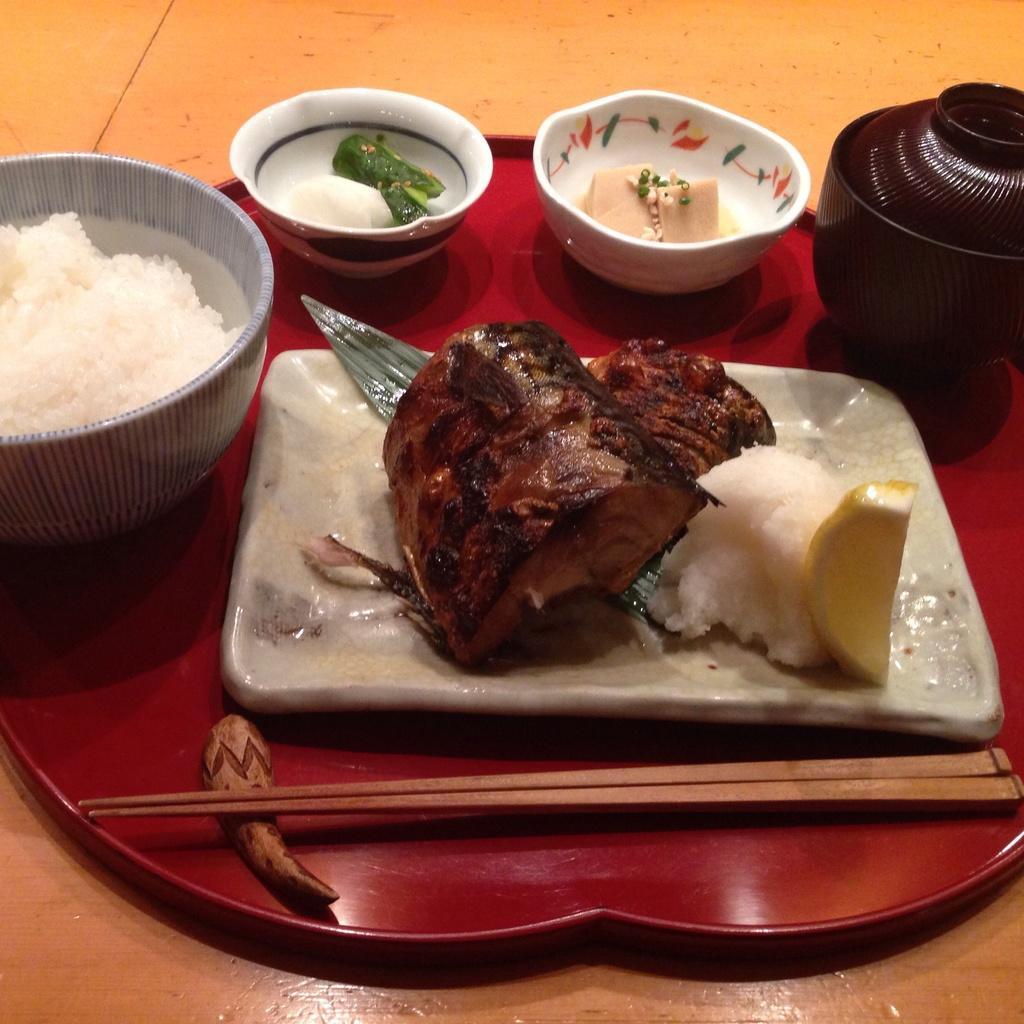Could you give a brief overview of what you see in this image? In this image I can see the plate and the bowls with food. To the side I can see the chopsticks. These are on the red color board. The board is on the brown color surface. 